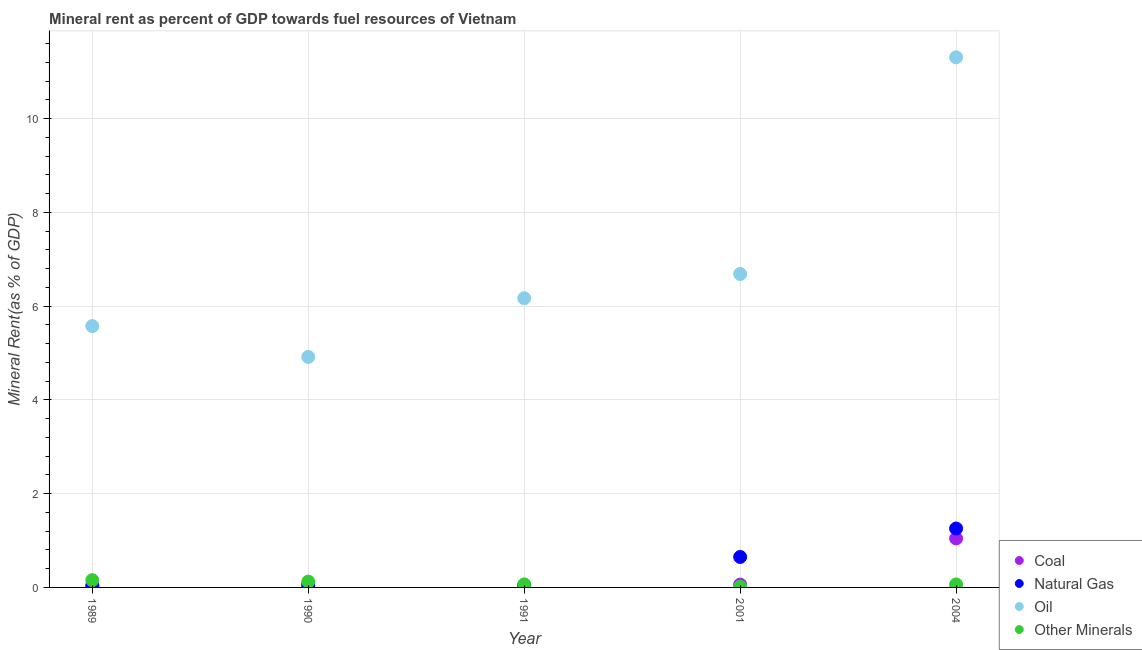How many different coloured dotlines are there?
Your response must be concise. 4. Is the number of dotlines equal to the number of legend labels?
Offer a very short reply. Yes. What is the  rent of other minerals in 2004?
Ensure brevity in your answer.  0.06. Across all years, what is the maximum natural gas rent?
Ensure brevity in your answer.  1.26. Across all years, what is the minimum coal rent?
Keep it short and to the point. 0.04. In which year was the coal rent minimum?
Your answer should be very brief. 1991. What is the total oil rent in the graph?
Provide a succinct answer. 34.66. What is the difference between the natural gas rent in 1989 and that in 2001?
Ensure brevity in your answer.  -0.63. What is the difference between the oil rent in 2001 and the  rent of other minerals in 1991?
Give a very brief answer. 6.62. What is the average  rent of other minerals per year?
Your answer should be compact. 0.08. In the year 1991, what is the difference between the  rent of other minerals and oil rent?
Keep it short and to the point. -6.11. In how many years, is the oil rent greater than 9.6 %?
Your answer should be compact. 1. What is the ratio of the oil rent in 1990 to that in 2004?
Your response must be concise. 0.43. Is the difference between the coal rent in 1989 and 1990 greater than the difference between the  rent of other minerals in 1989 and 1990?
Give a very brief answer. No. What is the difference between the highest and the second highest natural gas rent?
Make the answer very short. 0.61. What is the difference between the highest and the lowest  rent of other minerals?
Give a very brief answer. 0.14. In how many years, is the coal rent greater than the average coal rent taken over all years?
Your answer should be very brief. 1. Is the sum of the  rent of other minerals in 1989 and 2001 greater than the maximum natural gas rent across all years?
Make the answer very short. No. Is it the case that in every year, the sum of the coal rent and natural gas rent is greater than the oil rent?
Your response must be concise. No. Are the values on the major ticks of Y-axis written in scientific E-notation?
Provide a short and direct response. No. How are the legend labels stacked?
Ensure brevity in your answer.  Vertical. What is the title of the graph?
Offer a very short reply. Mineral rent as percent of GDP towards fuel resources of Vietnam. Does "Grants and Revenue" appear as one of the legend labels in the graph?
Offer a very short reply. No. What is the label or title of the Y-axis?
Provide a short and direct response. Mineral Rent(as % of GDP). What is the Mineral Rent(as % of GDP) of Coal in 1989?
Keep it short and to the point. 0.05. What is the Mineral Rent(as % of GDP) of Natural Gas in 1989?
Give a very brief answer. 0.02. What is the Mineral Rent(as % of GDP) in Oil in 1989?
Your answer should be compact. 5.57. What is the Mineral Rent(as % of GDP) of Other Minerals in 1989?
Make the answer very short. 0.15. What is the Mineral Rent(as % of GDP) in Coal in 1990?
Provide a short and direct response. 0.07. What is the Mineral Rent(as % of GDP) of Natural Gas in 1990?
Make the answer very short. 0.04. What is the Mineral Rent(as % of GDP) in Oil in 1990?
Ensure brevity in your answer.  4.92. What is the Mineral Rent(as % of GDP) in Other Minerals in 1990?
Offer a very short reply. 0.12. What is the Mineral Rent(as % of GDP) of Coal in 1991?
Provide a short and direct response. 0.04. What is the Mineral Rent(as % of GDP) of Natural Gas in 1991?
Ensure brevity in your answer.  0.05. What is the Mineral Rent(as % of GDP) of Oil in 1991?
Your answer should be compact. 6.17. What is the Mineral Rent(as % of GDP) in Other Minerals in 1991?
Your response must be concise. 0.06. What is the Mineral Rent(as % of GDP) of Coal in 2001?
Offer a very short reply. 0.06. What is the Mineral Rent(as % of GDP) of Natural Gas in 2001?
Offer a very short reply. 0.65. What is the Mineral Rent(as % of GDP) of Oil in 2001?
Provide a short and direct response. 6.69. What is the Mineral Rent(as % of GDP) in Other Minerals in 2001?
Ensure brevity in your answer.  0.01. What is the Mineral Rent(as % of GDP) in Coal in 2004?
Keep it short and to the point. 1.04. What is the Mineral Rent(as % of GDP) of Natural Gas in 2004?
Give a very brief answer. 1.26. What is the Mineral Rent(as % of GDP) of Oil in 2004?
Provide a short and direct response. 11.31. What is the Mineral Rent(as % of GDP) in Other Minerals in 2004?
Offer a very short reply. 0.06. Across all years, what is the maximum Mineral Rent(as % of GDP) in Coal?
Your response must be concise. 1.04. Across all years, what is the maximum Mineral Rent(as % of GDP) in Natural Gas?
Ensure brevity in your answer.  1.26. Across all years, what is the maximum Mineral Rent(as % of GDP) in Oil?
Keep it short and to the point. 11.31. Across all years, what is the maximum Mineral Rent(as % of GDP) of Other Minerals?
Make the answer very short. 0.15. Across all years, what is the minimum Mineral Rent(as % of GDP) in Coal?
Your answer should be very brief. 0.04. Across all years, what is the minimum Mineral Rent(as % of GDP) of Natural Gas?
Your answer should be very brief. 0.02. Across all years, what is the minimum Mineral Rent(as % of GDP) of Oil?
Provide a short and direct response. 4.92. Across all years, what is the minimum Mineral Rent(as % of GDP) in Other Minerals?
Give a very brief answer. 0.01. What is the total Mineral Rent(as % of GDP) in Coal in the graph?
Keep it short and to the point. 1.26. What is the total Mineral Rent(as % of GDP) of Natural Gas in the graph?
Ensure brevity in your answer.  2.01. What is the total Mineral Rent(as % of GDP) of Oil in the graph?
Keep it short and to the point. 34.66. What is the total Mineral Rent(as % of GDP) of Other Minerals in the graph?
Offer a terse response. 0.42. What is the difference between the Mineral Rent(as % of GDP) of Coal in 1989 and that in 1990?
Provide a succinct answer. -0.02. What is the difference between the Mineral Rent(as % of GDP) in Natural Gas in 1989 and that in 1990?
Your response must be concise. -0.01. What is the difference between the Mineral Rent(as % of GDP) of Oil in 1989 and that in 1990?
Provide a succinct answer. 0.66. What is the difference between the Mineral Rent(as % of GDP) of Other Minerals in 1989 and that in 1990?
Make the answer very short. 0.03. What is the difference between the Mineral Rent(as % of GDP) of Coal in 1989 and that in 1991?
Keep it short and to the point. 0.01. What is the difference between the Mineral Rent(as % of GDP) of Natural Gas in 1989 and that in 1991?
Give a very brief answer. -0.02. What is the difference between the Mineral Rent(as % of GDP) in Oil in 1989 and that in 1991?
Offer a terse response. -0.6. What is the difference between the Mineral Rent(as % of GDP) of Other Minerals in 1989 and that in 1991?
Your answer should be very brief. 0.09. What is the difference between the Mineral Rent(as % of GDP) of Coal in 1989 and that in 2001?
Give a very brief answer. -0.01. What is the difference between the Mineral Rent(as % of GDP) of Natural Gas in 1989 and that in 2001?
Provide a short and direct response. -0.63. What is the difference between the Mineral Rent(as % of GDP) in Oil in 1989 and that in 2001?
Your answer should be very brief. -1.11. What is the difference between the Mineral Rent(as % of GDP) in Other Minerals in 1989 and that in 2001?
Offer a terse response. 0.14. What is the difference between the Mineral Rent(as % of GDP) in Coal in 1989 and that in 2004?
Your response must be concise. -1. What is the difference between the Mineral Rent(as % of GDP) in Natural Gas in 1989 and that in 2004?
Provide a short and direct response. -1.23. What is the difference between the Mineral Rent(as % of GDP) in Oil in 1989 and that in 2004?
Keep it short and to the point. -5.73. What is the difference between the Mineral Rent(as % of GDP) in Other Minerals in 1989 and that in 2004?
Offer a terse response. 0.09. What is the difference between the Mineral Rent(as % of GDP) in Coal in 1990 and that in 1991?
Your answer should be very brief. 0.04. What is the difference between the Mineral Rent(as % of GDP) of Natural Gas in 1990 and that in 1991?
Offer a very short reply. -0.01. What is the difference between the Mineral Rent(as % of GDP) in Oil in 1990 and that in 1991?
Offer a terse response. -1.25. What is the difference between the Mineral Rent(as % of GDP) of Other Minerals in 1990 and that in 1991?
Offer a terse response. 0.06. What is the difference between the Mineral Rent(as % of GDP) in Coal in 1990 and that in 2001?
Keep it short and to the point. 0.01. What is the difference between the Mineral Rent(as % of GDP) of Natural Gas in 1990 and that in 2001?
Your answer should be compact. -0.61. What is the difference between the Mineral Rent(as % of GDP) in Oil in 1990 and that in 2001?
Your response must be concise. -1.77. What is the difference between the Mineral Rent(as % of GDP) in Other Minerals in 1990 and that in 2001?
Your answer should be compact. 0.11. What is the difference between the Mineral Rent(as % of GDP) of Coal in 1990 and that in 2004?
Your answer should be very brief. -0.97. What is the difference between the Mineral Rent(as % of GDP) of Natural Gas in 1990 and that in 2004?
Provide a succinct answer. -1.22. What is the difference between the Mineral Rent(as % of GDP) in Oil in 1990 and that in 2004?
Your answer should be compact. -6.39. What is the difference between the Mineral Rent(as % of GDP) in Other Minerals in 1990 and that in 2004?
Provide a short and direct response. 0.06. What is the difference between the Mineral Rent(as % of GDP) in Coal in 1991 and that in 2001?
Your answer should be compact. -0.02. What is the difference between the Mineral Rent(as % of GDP) in Natural Gas in 1991 and that in 2001?
Provide a succinct answer. -0.6. What is the difference between the Mineral Rent(as % of GDP) of Oil in 1991 and that in 2001?
Make the answer very short. -0.52. What is the difference between the Mineral Rent(as % of GDP) of Other Minerals in 1991 and that in 2001?
Your answer should be compact. 0.05. What is the difference between the Mineral Rent(as % of GDP) of Coal in 1991 and that in 2004?
Keep it short and to the point. -1.01. What is the difference between the Mineral Rent(as % of GDP) in Natural Gas in 1991 and that in 2004?
Provide a short and direct response. -1.21. What is the difference between the Mineral Rent(as % of GDP) in Oil in 1991 and that in 2004?
Your response must be concise. -5.14. What is the difference between the Mineral Rent(as % of GDP) in Other Minerals in 1991 and that in 2004?
Offer a terse response. 0. What is the difference between the Mineral Rent(as % of GDP) of Coal in 2001 and that in 2004?
Make the answer very short. -0.98. What is the difference between the Mineral Rent(as % of GDP) of Natural Gas in 2001 and that in 2004?
Ensure brevity in your answer.  -0.61. What is the difference between the Mineral Rent(as % of GDP) of Oil in 2001 and that in 2004?
Provide a short and direct response. -4.62. What is the difference between the Mineral Rent(as % of GDP) of Other Minerals in 2001 and that in 2004?
Provide a succinct answer. -0.05. What is the difference between the Mineral Rent(as % of GDP) of Coal in 1989 and the Mineral Rent(as % of GDP) of Natural Gas in 1990?
Offer a terse response. 0.01. What is the difference between the Mineral Rent(as % of GDP) of Coal in 1989 and the Mineral Rent(as % of GDP) of Oil in 1990?
Offer a very short reply. -4.87. What is the difference between the Mineral Rent(as % of GDP) in Coal in 1989 and the Mineral Rent(as % of GDP) in Other Minerals in 1990?
Give a very brief answer. -0.08. What is the difference between the Mineral Rent(as % of GDP) in Natural Gas in 1989 and the Mineral Rent(as % of GDP) in Oil in 1990?
Offer a very short reply. -4.89. What is the difference between the Mineral Rent(as % of GDP) in Natural Gas in 1989 and the Mineral Rent(as % of GDP) in Other Minerals in 1990?
Keep it short and to the point. -0.1. What is the difference between the Mineral Rent(as % of GDP) of Oil in 1989 and the Mineral Rent(as % of GDP) of Other Minerals in 1990?
Your response must be concise. 5.45. What is the difference between the Mineral Rent(as % of GDP) in Coal in 1989 and the Mineral Rent(as % of GDP) in Natural Gas in 1991?
Give a very brief answer. 0. What is the difference between the Mineral Rent(as % of GDP) of Coal in 1989 and the Mineral Rent(as % of GDP) of Oil in 1991?
Give a very brief answer. -6.12. What is the difference between the Mineral Rent(as % of GDP) in Coal in 1989 and the Mineral Rent(as % of GDP) in Other Minerals in 1991?
Give a very brief answer. -0.02. What is the difference between the Mineral Rent(as % of GDP) of Natural Gas in 1989 and the Mineral Rent(as % of GDP) of Oil in 1991?
Offer a very short reply. -6.15. What is the difference between the Mineral Rent(as % of GDP) of Natural Gas in 1989 and the Mineral Rent(as % of GDP) of Other Minerals in 1991?
Your answer should be very brief. -0.04. What is the difference between the Mineral Rent(as % of GDP) in Oil in 1989 and the Mineral Rent(as % of GDP) in Other Minerals in 1991?
Keep it short and to the point. 5.51. What is the difference between the Mineral Rent(as % of GDP) in Coal in 1989 and the Mineral Rent(as % of GDP) in Natural Gas in 2001?
Provide a succinct answer. -0.6. What is the difference between the Mineral Rent(as % of GDP) of Coal in 1989 and the Mineral Rent(as % of GDP) of Oil in 2001?
Your answer should be very brief. -6.64. What is the difference between the Mineral Rent(as % of GDP) of Coal in 1989 and the Mineral Rent(as % of GDP) of Other Minerals in 2001?
Your response must be concise. 0.03. What is the difference between the Mineral Rent(as % of GDP) of Natural Gas in 1989 and the Mineral Rent(as % of GDP) of Oil in 2001?
Your response must be concise. -6.66. What is the difference between the Mineral Rent(as % of GDP) in Natural Gas in 1989 and the Mineral Rent(as % of GDP) in Other Minerals in 2001?
Make the answer very short. 0.01. What is the difference between the Mineral Rent(as % of GDP) of Oil in 1989 and the Mineral Rent(as % of GDP) of Other Minerals in 2001?
Offer a very short reply. 5.56. What is the difference between the Mineral Rent(as % of GDP) in Coal in 1989 and the Mineral Rent(as % of GDP) in Natural Gas in 2004?
Offer a terse response. -1.21. What is the difference between the Mineral Rent(as % of GDP) in Coal in 1989 and the Mineral Rent(as % of GDP) in Oil in 2004?
Keep it short and to the point. -11.26. What is the difference between the Mineral Rent(as % of GDP) in Coal in 1989 and the Mineral Rent(as % of GDP) in Other Minerals in 2004?
Provide a short and direct response. -0.02. What is the difference between the Mineral Rent(as % of GDP) in Natural Gas in 1989 and the Mineral Rent(as % of GDP) in Oil in 2004?
Provide a short and direct response. -11.28. What is the difference between the Mineral Rent(as % of GDP) in Natural Gas in 1989 and the Mineral Rent(as % of GDP) in Other Minerals in 2004?
Offer a very short reply. -0.04. What is the difference between the Mineral Rent(as % of GDP) of Oil in 1989 and the Mineral Rent(as % of GDP) of Other Minerals in 2004?
Your response must be concise. 5.51. What is the difference between the Mineral Rent(as % of GDP) in Coal in 1990 and the Mineral Rent(as % of GDP) in Natural Gas in 1991?
Offer a terse response. 0.03. What is the difference between the Mineral Rent(as % of GDP) in Coal in 1990 and the Mineral Rent(as % of GDP) in Oil in 1991?
Offer a terse response. -6.1. What is the difference between the Mineral Rent(as % of GDP) in Coal in 1990 and the Mineral Rent(as % of GDP) in Other Minerals in 1991?
Your response must be concise. 0.01. What is the difference between the Mineral Rent(as % of GDP) in Natural Gas in 1990 and the Mineral Rent(as % of GDP) in Oil in 1991?
Provide a succinct answer. -6.13. What is the difference between the Mineral Rent(as % of GDP) of Natural Gas in 1990 and the Mineral Rent(as % of GDP) of Other Minerals in 1991?
Provide a succinct answer. -0.03. What is the difference between the Mineral Rent(as % of GDP) of Oil in 1990 and the Mineral Rent(as % of GDP) of Other Minerals in 1991?
Offer a terse response. 4.85. What is the difference between the Mineral Rent(as % of GDP) of Coal in 1990 and the Mineral Rent(as % of GDP) of Natural Gas in 2001?
Make the answer very short. -0.58. What is the difference between the Mineral Rent(as % of GDP) of Coal in 1990 and the Mineral Rent(as % of GDP) of Oil in 2001?
Ensure brevity in your answer.  -6.61. What is the difference between the Mineral Rent(as % of GDP) in Coal in 1990 and the Mineral Rent(as % of GDP) in Other Minerals in 2001?
Offer a terse response. 0.06. What is the difference between the Mineral Rent(as % of GDP) of Natural Gas in 1990 and the Mineral Rent(as % of GDP) of Oil in 2001?
Ensure brevity in your answer.  -6.65. What is the difference between the Mineral Rent(as % of GDP) of Natural Gas in 1990 and the Mineral Rent(as % of GDP) of Other Minerals in 2001?
Offer a terse response. 0.02. What is the difference between the Mineral Rent(as % of GDP) in Oil in 1990 and the Mineral Rent(as % of GDP) in Other Minerals in 2001?
Ensure brevity in your answer.  4.9. What is the difference between the Mineral Rent(as % of GDP) of Coal in 1990 and the Mineral Rent(as % of GDP) of Natural Gas in 2004?
Offer a terse response. -1.19. What is the difference between the Mineral Rent(as % of GDP) of Coal in 1990 and the Mineral Rent(as % of GDP) of Oil in 2004?
Your answer should be very brief. -11.24. What is the difference between the Mineral Rent(as % of GDP) of Coal in 1990 and the Mineral Rent(as % of GDP) of Other Minerals in 2004?
Make the answer very short. 0.01. What is the difference between the Mineral Rent(as % of GDP) of Natural Gas in 1990 and the Mineral Rent(as % of GDP) of Oil in 2004?
Offer a very short reply. -11.27. What is the difference between the Mineral Rent(as % of GDP) of Natural Gas in 1990 and the Mineral Rent(as % of GDP) of Other Minerals in 2004?
Your answer should be very brief. -0.03. What is the difference between the Mineral Rent(as % of GDP) of Oil in 1990 and the Mineral Rent(as % of GDP) of Other Minerals in 2004?
Provide a succinct answer. 4.85. What is the difference between the Mineral Rent(as % of GDP) in Coal in 1991 and the Mineral Rent(as % of GDP) in Natural Gas in 2001?
Provide a succinct answer. -0.61. What is the difference between the Mineral Rent(as % of GDP) of Coal in 1991 and the Mineral Rent(as % of GDP) of Oil in 2001?
Make the answer very short. -6.65. What is the difference between the Mineral Rent(as % of GDP) in Coal in 1991 and the Mineral Rent(as % of GDP) in Other Minerals in 2001?
Make the answer very short. 0.02. What is the difference between the Mineral Rent(as % of GDP) of Natural Gas in 1991 and the Mineral Rent(as % of GDP) of Oil in 2001?
Keep it short and to the point. -6.64. What is the difference between the Mineral Rent(as % of GDP) of Natural Gas in 1991 and the Mineral Rent(as % of GDP) of Other Minerals in 2001?
Keep it short and to the point. 0.03. What is the difference between the Mineral Rent(as % of GDP) in Oil in 1991 and the Mineral Rent(as % of GDP) in Other Minerals in 2001?
Make the answer very short. 6.16. What is the difference between the Mineral Rent(as % of GDP) in Coal in 1991 and the Mineral Rent(as % of GDP) in Natural Gas in 2004?
Your answer should be very brief. -1.22. What is the difference between the Mineral Rent(as % of GDP) of Coal in 1991 and the Mineral Rent(as % of GDP) of Oil in 2004?
Your response must be concise. -11.27. What is the difference between the Mineral Rent(as % of GDP) of Coal in 1991 and the Mineral Rent(as % of GDP) of Other Minerals in 2004?
Provide a succinct answer. -0.03. What is the difference between the Mineral Rent(as % of GDP) in Natural Gas in 1991 and the Mineral Rent(as % of GDP) in Oil in 2004?
Your response must be concise. -11.26. What is the difference between the Mineral Rent(as % of GDP) in Natural Gas in 1991 and the Mineral Rent(as % of GDP) in Other Minerals in 2004?
Provide a succinct answer. -0.02. What is the difference between the Mineral Rent(as % of GDP) of Oil in 1991 and the Mineral Rent(as % of GDP) of Other Minerals in 2004?
Offer a terse response. 6.11. What is the difference between the Mineral Rent(as % of GDP) in Coal in 2001 and the Mineral Rent(as % of GDP) in Natural Gas in 2004?
Your answer should be very brief. -1.2. What is the difference between the Mineral Rent(as % of GDP) in Coal in 2001 and the Mineral Rent(as % of GDP) in Oil in 2004?
Offer a terse response. -11.25. What is the difference between the Mineral Rent(as % of GDP) of Coal in 2001 and the Mineral Rent(as % of GDP) of Other Minerals in 2004?
Provide a succinct answer. -0. What is the difference between the Mineral Rent(as % of GDP) in Natural Gas in 2001 and the Mineral Rent(as % of GDP) in Oil in 2004?
Make the answer very short. -10.66. What is the difference between the Mineral Rent(as % of GDP) of Natural Gas in 2001 and the Mineral Rent(as % of GDP) of Other Minerals in 2004?
Provide a succinct answer. 0.59. What is the difference between the Mineral Rent(as % of GDP) in Oil in 2001 and the Mineral Rent(as % of GDP) in Other Minerals in 2004?
Offer a terse response. 6.62. What is the average Mineral Rent(as % of GDP) in Coal per year?
Your answer should be very brief. 0.25. What is the average Mineral Rent(as % of GDP) in Natural Gas per year?
Give a very brief answer. 0.4. What is the average Mineral Rent(as % of GDP) of Oil per year?
Make the answer very short. 6.93. What is the average Mineral Rent(as % of GDP) of Other Minerals per year?
Provide a short and direct response. 0.08. In the year 1989, what is the difference between the Mineral Rent(as % of GDP) of Coal and Mineral Rent(as % of GDP) of Natural Gas?
Provide a succinct answer. 0.02. In the year 1989, what is the difference between the Mineral Rent(as % of GDP) in Coal and Mineral Rent(as % of GDP) in Oil?
Your answer should be compact. -5.53. In the year 1989, what is the difference between the Mineral Rent(as % of GDP) in Coal and Mineral Rent(as % of GDP) in Other Minerals?
Provide a succinct answer. -0.11. In the year 1989, what is the difference between the Mineral Rent(as % of GDP) of Natural Gas and Mineral Rent(as % of GDP) of Oil?
Your answer should be compact. -5.55. In the year 1989, what is the difference between the Mineral Rent(as % of GDP) of Natural Gas and Mineral Rent(as % of GDP) of Other Minerals?
Provide a short and direct response. -0.13. In the year 1989, what is the difference between the Mineral Rent(as % of GDP) of Oil and Mineral Rent(as % of GDP) of Other Minerals?
Offer a very short reply. 5.42. In the year 1990, what is the difference between the Mineral Rent(as % of GDP) of Coal and Mineral Rent(as % of GDP) of Natural Gas?
Provide a succinct answer. 0.03. In the year 1990, what is the difference between the Mineral Rent(as % of GDP) in Coal and Mineral Rent(as % of GDP) in Oil?
Your answer should be compact. -4.85. In the year 1990, what is the difference between the Mineral Rent(as % of GDP) of Coal and Mineral Rent(as % of GDP) of Other Minerals?
Ensure brevity in your answer.  -0.05. In the year 1990, what is the difference between the Mineral Rent(as % of GDP) of Natural Gas and Mineral Rent(as % of GDP) of Oil?
Your answer should be compact. -4.88. In the year 1990, what is the difference between the Mineral Rent(as % of GDP) of Natural Gas and Mineral Rent(as % of GDP) of Other Minerals?
Give a very brief answer. -0.09. In the year 1990, what is the difference between the Mineral Rent(as % of GDP) in Oil and Mineral Rent(as % of GDP) in Other Minerals?
Your response must be concise. 4.79. In the year 1991, what is the difference between the Mineral Rent(as % of GDP) of Coal and Mineral Rent(as % of GDP) of Natural Gas?
Give a very brief answer. -0.01. In the year 1991, what is the difference between the Mineral Rent(as % of GDP) in Coal and Mineral Rent(as % of GDP) in Oil?
Keep it short and to the point. -6.13. In the year 1991, what is the difference between the Mineral Rent(as % of GDP) in Coal and Mineral Rent(as % of GDP) in Other Minerals?
Your answer should be very brief. -0.03. In the year 1991, what is the difference between the Mineral Rent(as % of GDP) in Natural Gas and Mineral Rent(as % of GDP) in Oil?
Your answer should be very brief. -6.12. In the year 1991, what is the difference between the Mineral Rent(as % of GDP) of Natural Gas and Mineral Rent(as % of GDP) of Other Minerals?
Your response must be concise. -0.02. In the year 1991, what is the difference between the Mineral Rent(as % of GDP) of Oil and Mineral Rent(as % of GDP) of Other Minerals?
Offer a terse response. 6.11. In the year 2001, what is the difference between the Mineral Rent(as % of GDP) of Coal and Mineral Rent(as % of GDP) of Natural Gas?
Offer a terse response. -0.59. In the year 2001, what is the difference between the Mineral Rent(as % of GDP) of Coal and Mineral Rent(as % of GDP) of Oil?
Give a very brief answer. -6.63. In the year 2001, what is the difference between the Mineral Rent(as % of GDP) in Coal and Mineral Rent(as % of GDP) in Other Minerals?
Your answer should be compact. 0.05. In the year 2001, what is the difference between the Mineral Rent(as % of GDP) of Natural Gas and Mineral Rent(as % of GDP) of Oil?
Provide a short and direct response. -6.04. In the year 2001, what is the difference between the Mineral Rent(as % of GDP) in Natural Gas and Mineral Rent(as % of GDP) in Other Minerals?
Provide a short and direct response. 0.64. In the year 2001, what is the difference between the Mineral Rent(as % of GDP) of Oil and Mineral Rent(as % of GDP) of Other Minerals?
Provide a short and direct response. 6.67. In the year 2004, what is the difference between the Mineral Rent(as % of GDP) of Coal and Mineral Rent(as % of GDP) of Natural Gas?
Make the answer very short. -0.21. In the year 2004, what is the difference between the Mineral Rent(as % of GDP) of Coal and Mineral Rent(as % of GDP) of Oil?
Give a very brief answer. -10.26. In the year 2004, what is the difference between the Mineral Rent(as % of GDP) of Coal and Mineral Rent(as % of GDP) of Other Minerals?
Give a very brief answer. 0.98. In the year 2004, what is the difference between the Mineral Rent(as % of GDP) of Natural Gas and Mineral Rent(as % of GDP) of Oil?
Keep it short and to the point. -10.05. In the year 2004, what is the difference between the Mineral Rent(as % of GDP) of Natural Gas and Mineral Rent(as % of GDP) of Other Minerals?
Give a very brief answer. 1.19. In the year 2004, what is the difference between the Mineral Rent(as % of GDP) in Oil and Mineral Rent(as % of GDP) in Other Minerals?
Your response must be concise. 11.24. What is the ratio of the Mineral Rent(as % of GDP) of Coal in 1989 to that in 1990?
Offer a terse response. 0.67. What is the ratio of the Mineral Rent(as % of GDP) of Natural Gas in 1989 to that in 1990?
Your answer should be compact. 0.66. What is the ratio of the Mineral Rent(as % of GDP) in Oil in 1989 to that in 1990?
Offer a very short reply. 1.13. What is the ratio of the Mineral Rent(as % of GDP) in Other Minerals in 1989 to that in 1990?
Keep it short and to the point. 1.25. What is the ratio of the Mineral Rent(as % of GDP) in Coal in 1989 to that in 1991?
Ensure brevity in your answer.  1.33. What is the ratio of the Mineral Rent(as % of GDP) in Natural Gas in 1989 to that in 1991?
Offer a very short reply. 0.53. What is the ratio of the Mineral Rent(as % of GDP) in Oil in 1989 to that in 1991?
Make the answer very short. 0.9. What is the ratio of the Mineral Rent(as % of GDP) in Other Minerals in 1989 to that in 1991?
Give a very brief answer. 2.41. What is the ratio of the Mineral Rent(as % of GDP) in Coal in 1989 to that in 2001?
Make the answer very short. 0.8. What is the ratio of the Mineral Rent(as % of GDP) of Natural Gas in 1989 to that in 2001?
Provide a succinct answer. 0.04. What is the ratio of the Mineral Rent(as % of GDP) of Oil in 1989 to that in 2001?
Provide a short and direct response. 0.83. What is the ratio of the Mineral Rent(as % of GDP) in Other Minerals in 1989 to that in 2001?
Make the answer very short. 10.33. What is the ratio of the Mineral Rent(as % of GDP) in Coal in 1989 to that in 2004?
Offer a very short reply. 0.05. What is the ratio of the Mineral Rent(as % of GDP) of Natural Gas in 1989 to that in 2004?
Offer a terse response. 0.02. What is the ratio of the Mineral Rent(as % of GDP) of Oil in 1989 to that in 2004?
Offer a very short reply. 0.49. What is the ratio of the Mineral Rent(as % of GDP) of Other Minerals in 1989 to that in 2004?
Your response must be concise. 2.43. What is the ratio of the Mineral Rent(as % of GDP) of Coal in 1990 to that in 1991?
Your answer should be compact. 2.01. What is the ratio of the Mineral Rent(as % of GDP) of Natural Gas in 1990 to that in 1991?
Keep it short and to the point. 0.81. What is the ratio of the Mineral Rent(as % of GDP) in Oil in 1990 to that in 1991?
Give a very brief answer. 0.8. What is the ratio of the Mineral Rent(as % of GDP) in Other Minerals in 1990 to that in 1991?
Offer a terse response. 1.93. What is the ratio of the Mineral Rent(as % of GDP) of Coal in 1990 to that in 2001?
Keep it short and to the point. 1.2. What is the ratio of the Mineral Rent(as % of GDP) of Natural Gas in 1990 to that in 2001?
Make the answer very short. 0.06. What is the ratio of the Mineral Rent(as % of GDP) in Oil in 1990 to that in 2001?
Your answer should be very brief. 0.74. What is the ratio of the Mineral Rent(as % of GDP) of Other Minerals in 1990 to that in 2001?
Offer a terse response. 8.27. What is the ratio of the Mineral Rent(as % of GDP) in Coal in 1990 to that in 2004?
Keep it short and to the point. 0.07. What is the ratio of the Mineral Rent(as % of GDP) of Natural Gas in 1990 to that in 2004?
Your answer should be very brief. 0.03. What is the ratio of the Mineral Rent(as % of GDP) of Oil in 1990 to that in 2004?
Ensure brevity in your answer.  0.43. What is the ratio of the Mineral Rent(as % of GDP) in Other Minerals in 1990 to that in 2004?
Provide a short and direct response. 1.95. What is the ratio of the Mineral Rent(as % of GDP) in Coal in 1991 to that in 2001?
Ensure brevity in your answer.  0.6. What is the ratio of the Mineral Rent(as % of GDP) in Natural Gas in 1991 to that in 2001?
Keep it short and to the point. 0.07. What is the ratio of the Mineral Rent(as % of GDP) in Oil in 1991 to that in 2001?
Offer a very short reply. 0.92. What is the ratio of the Mineral Rent(as % of GDP) in Other Minerals in 1991 to that in 2001?
Your response must be concise. 4.29. What is the ratio of the Mineral Rent(as % of GDP) of Coal in 1991 to that in 2004?
Ensure brevity in your answer.  0.03. What is the ratio of the Mineral Rent(as % of GDP) of Natural Gas in 1991 to that in 2004?
Keep it short and to the point. 0.04. What is the ratio of the Mineral Rent(as % of GDP) in Oil in 1991 to that in 2004?
Offer a terse response. 0.55. What is the ratio of the Mineral Rent(as % of GDP) in Other Minerals in 1991 to that in 2004?
Your answer should be very brief. 1.01. What is the ratio of the Mineral Rent(as % of GDP) in Coal in 2001 to that in 2004?
Your response must be concise. 0.06. What is the ratio of the Mineral Rent(as % of GDP) of Natural Gas in 2001 to that in 2004?
Provide a succinct answer. 0.52. What is the ratio of the Mineral Rent(as % of GDP) in Oil in 2001 to that in 2004?
Your answer should be compact. 0.59. What is the ratio of the Mineral Rent(as % of GDP) of Other Minerals in 2001 to that in 2004?
Provide a short and direct response. 0.24. What is the difference between the highest and the second highest Mineral Rent(as % of GDP) in Coal?
Your response must be concise. 0.97. What is the difference between the highest and the second highest Mineral Rent(as % of GDP) in Natural Gas?
Provide a short and direct response. 0.61. What is the difference between the highest and the second highest Mineral Rent(as % of GDP) of Oil?
Ensure brevity in your answer.  4.62. What is the difference between the highest and the second highest Mineral Rent(as % of GDP) in Other Minerals?
Provide a succinct answer. 0.03. What is the difference between the highest and the lowest Mineral Rent(as % of GDP) in Coal?
Your response must be concise. 1.01. What is the difference between the highest and the lowest Mineral Rent(as % of GDP) in Natural Gas?
Provide a succinct answer. 1.23. What is the difference between the highest and the lowest Mineral Rent(as % of GDP) in Oil?
Your answer should be compact. 6.39. What is the difference between the highest and the lowest Mineral Rent(as % of GDP) of Other Minerals?
Offer a very short reply. 0.14. 